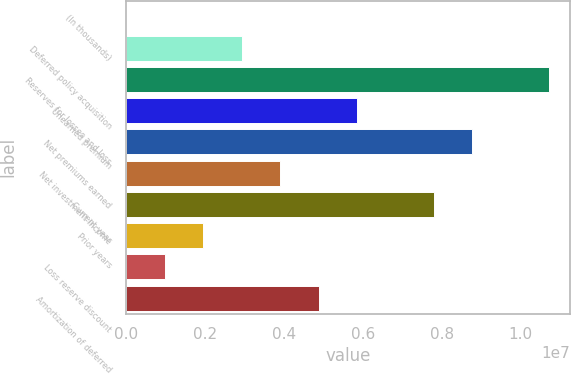<chart> <loc_0><loc_0><loc_500><loc_500><bar_chart><fcel>(In thousands)<fcel>Deferred policy acquisition<fcel>Reserves for losses and loss<fcel>Unearned premium<fcel>Net premiums earned<fcel>Net investment income<fcel>Current year<fcel>Prior years<fcel>Loss reserve discount<fcel>Amortization of deferred<nl><fcel>2012<fcel>2.92673e+06<fcel>1.0726e+07<fcel>5.85146e+06<fcel>8.77618e+06<fcel>3.90164e+06<fcel>7.80127e+06<fcel>1.95183e+06<fcel>976919<fcel>4.87655e+06<nl></chart> 